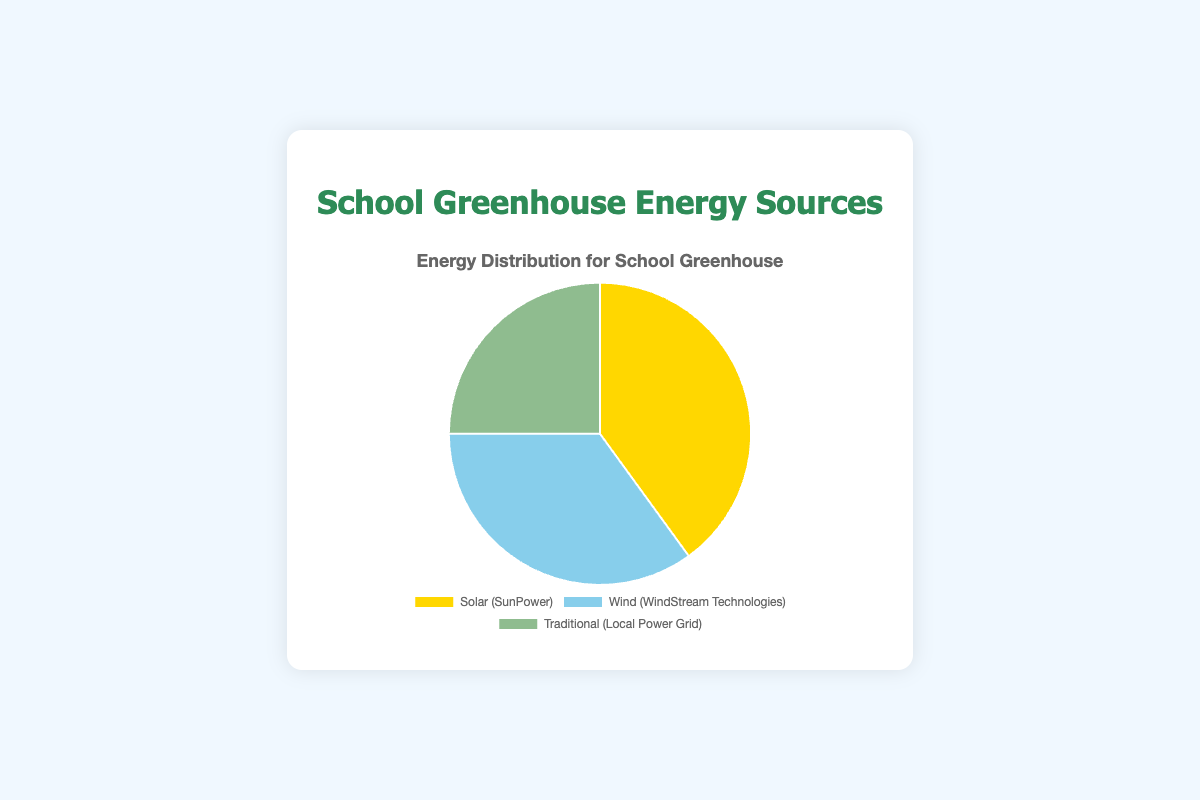In which energy source category does the highest percentage of the school greenhouse's energy come from? The pie chart shows the energy sources for the school greenhouse. The largest slice of the pie is labeled "Solar (SunPower)" with 40%. Thus, the highest percentage comes from solar energy.
Answer: Solar How much more energy percentage comes from Solar compared to Traditional sources? The percentage for Solar energy is 40%, and for Traditional sources, it is 25%. Subtract the Traditional percentage from the Solar percentage: 40% - 25% = 15%. So, Solar provides 15% more than Traditional.
Answer: 15% Which energy source contributes the least to the school greenhouse's energy? The smallest slice in the pie chart is labeled "Traditional (Local Power Grid)" with 25%. Hence, the Traditional source contributes the least.
Answer: Traditional What is the combined percentage of renewable energy sources (Solar and Wind)? The pie chart shows that Solar energy contributes 40% and Wind energy contributes 35%. Adding these percentages: 40% + 35% = 75%. Thus, renewable energy sources contribute 75% in total.
Answer: 75% By how much does Wind energy exceed Traditional energy in percentage? The pie chart indicates that Wind energy accounts for 35% and Traditional energy accounts for 25%. Subtract the Traditional percentage from the Wind percentage: 35% - 25% = 10%. Therefore, Wind exceeds Traditional by 10%.
Answer: 10% Which two energy sources together form a majority of the school greenhouse's energy supply? The pie chart segments show that Solar is 40% and Wind is 35%. Together, they make up 75%, which is more than half. Thus, Solar and Wind together form a majority of the energy supply.
Answer: Solar and Wind What percentage of the energy sources is not from renewable sources? The pie chart indicates that Traditional (Local Power Grid) is the only non-renewable source, contributing 25%. Thus, 25% of the energy is not from renewable sources.
Answer: 25% What is the difference in percentage between the largest and smallest energy sources? The largest energy source is Solar at 40%, and the smallest is Traditional at 25%. Subtract the smallest percentage from the largest: 40% - 25% = 15%. Hence, the difference is 15%.
Answer: 15% What does the pie chart predominantly represent, renewable or non-renewable energy sources? The pie chart shows 40% from Solar and 35% from Wind, which together comprise 75%, both renewable. The non-renewable source, Traditional, is only 25%. Since 75% is from renewable sources, the pie chart predominantly represents renewable energy.
Answer: Renewable 